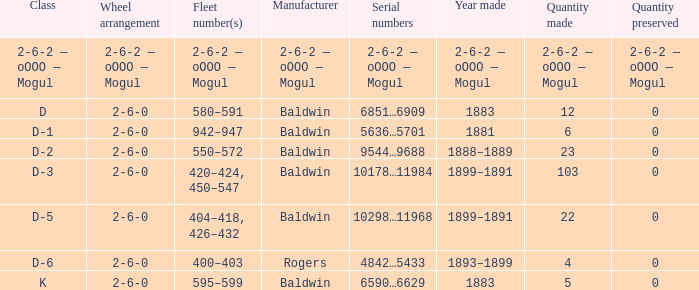Can you parse all the data within this table? {'header': ['Class', 'Wheel arrangement', 'Fleet number(s)', 'Manufacturer', 'Serial numbers', 'Year made', 'Quantity made', 'Quantity preserved'], 'rows': [['2-6-2 — oOOO — Mogul', '2-6-2 — oOOO — Mogul', '2-6-2 — oOOO — Mogul', '2-6-2 — oOOO — Mogul', '2-6-2 — oOOO — Mogul', '2-6-2 — oOOO — Mogul', '2-6-2 — oOOO — Mogul', '2-6-2 — oOOO — Mogul'], ['D', '2-6-0', '580–591', 'Baldwin', '6851…6909', '1883', '12', '0'], ['D-1', '2-6-0', '942–947', 'Baldwin', '5636…5701', '1881', '6', '0'], ['D-2', '2-6-0', '550–572', 'Baldwin', '9544…9688', '1888–1889', '23', '0'], ['D-3', '2-6-0', '420–424, 450–547', 'Baldwin', '10178…11984', '1899–1891', '103', '0'], ['D-5', '2-6-0', '404–418, 426–432', 'Baldwin', '10298…11968', '1899–1891', '22', '0'], ['D-6', '2-6-0', '400–403', 'Rogers', '4842…5433', '1893–1899', '4', '0'], ['K', '2-6-0', '595–599', 'Baldwin', '6590…6629', '1883', '5', '0']]} In which year was it made when the manufacturer is 2-6-2 — oooo — mogul? 2-6-2 — oOOO — Mogul. 